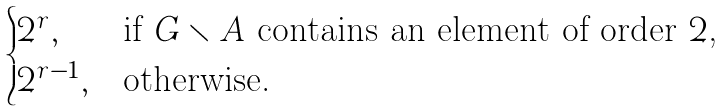<formula> <loc_0><loc_0><loc_500><loc_500>\begin{cases} 2 ^ { r } , & \text {if $G\smallsetminus A$ contains an element of order $2$,} \\ 2 ^ { r - 1 } , & \text {otherwise.} \end{cases}</formula> 